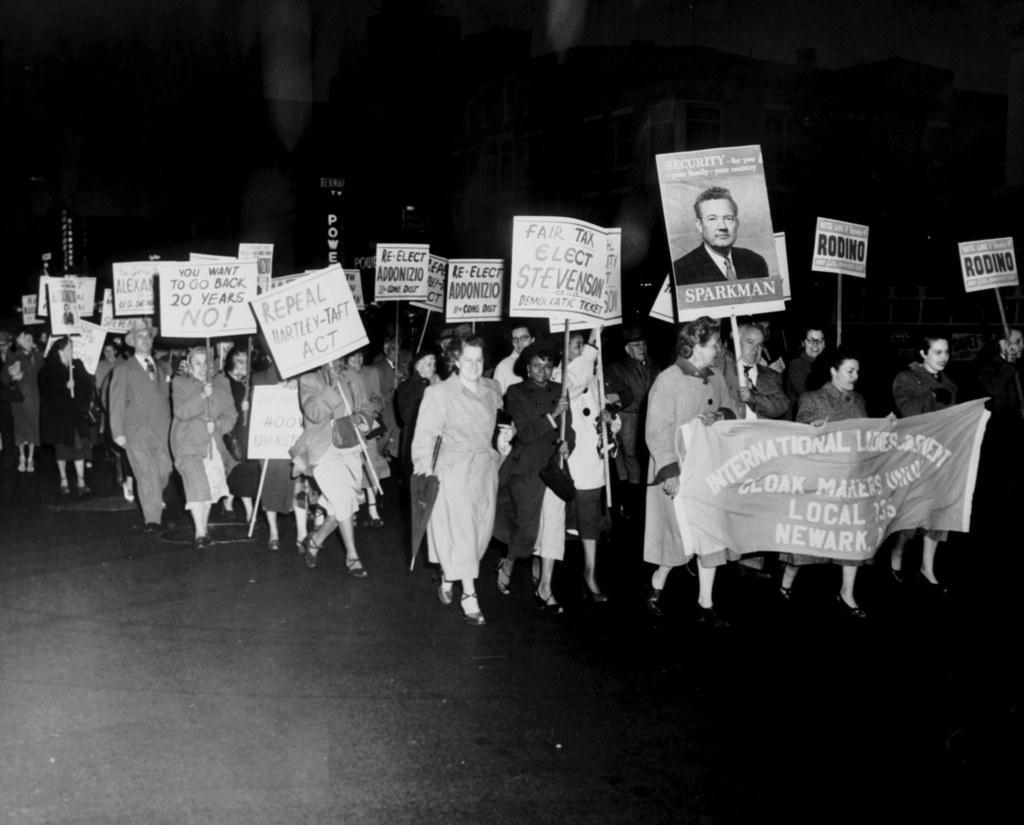In one or two sentences, can you explain what this image depicts? This is a black and white image. In this image we can see a group of people walking on the road. In that some are holding the boards with some text on it. On the right side we can see some people holding a banner. On the backside we can see a signboard. 